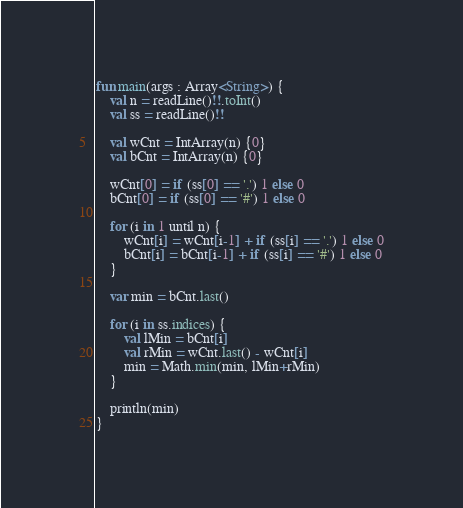<code> <loc_0><loc_0><loc_500><loc_500><_Kotlin_>fun main(args : Array<String>) {
    val n = readLine()!!.toInt()
    val ss = readLine()!!

    val wCnt = IntArray(n) {0}
    val bCnt = IntArray(n) {0}

    wCnt[0] = if (ss[0] == '.') 1 else 0
    bCnt[0] = if (ss[0] == '#') 1 else 0

    for (i in 1 until n) {
        wCnt[i] = wCnt[i-1] + if (ss[i] == '.') 1 else 0
        bCnt[i] = bCnt[i-1] + if (ss[i] == '#') 1 else 0
    }

    var min = bCnt.last()

    for (i in ss.indices) {
        val lMin = bCnt[i]
        val rMin = wCnt.last() - wCnt[i]
        min = Math.min(min, lMin+rMin)
    }

    println(min)
}</code> 